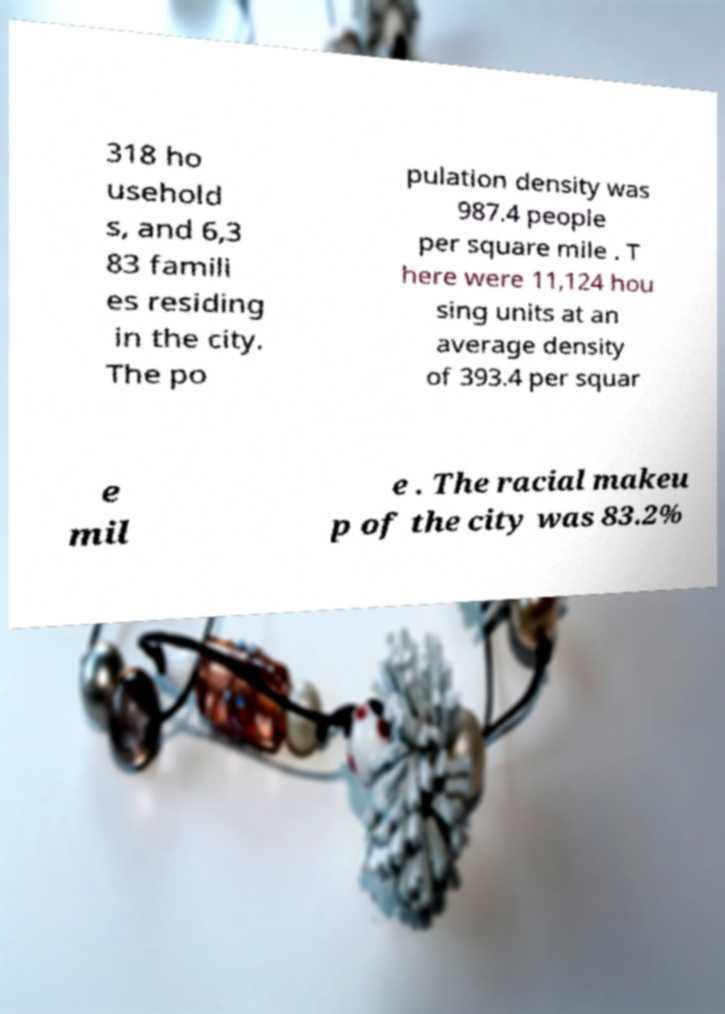Can you accurately transcribe the text from the provided image for me? 318 ho usehold s, and 6,3 83 famili es residing in the city. The po pulation density was 987.4 people per square mile . T here were 11,124 hou sing units at an average density of 393.4 per squar e mil e . The racial makeu p of the city was 83.2% 